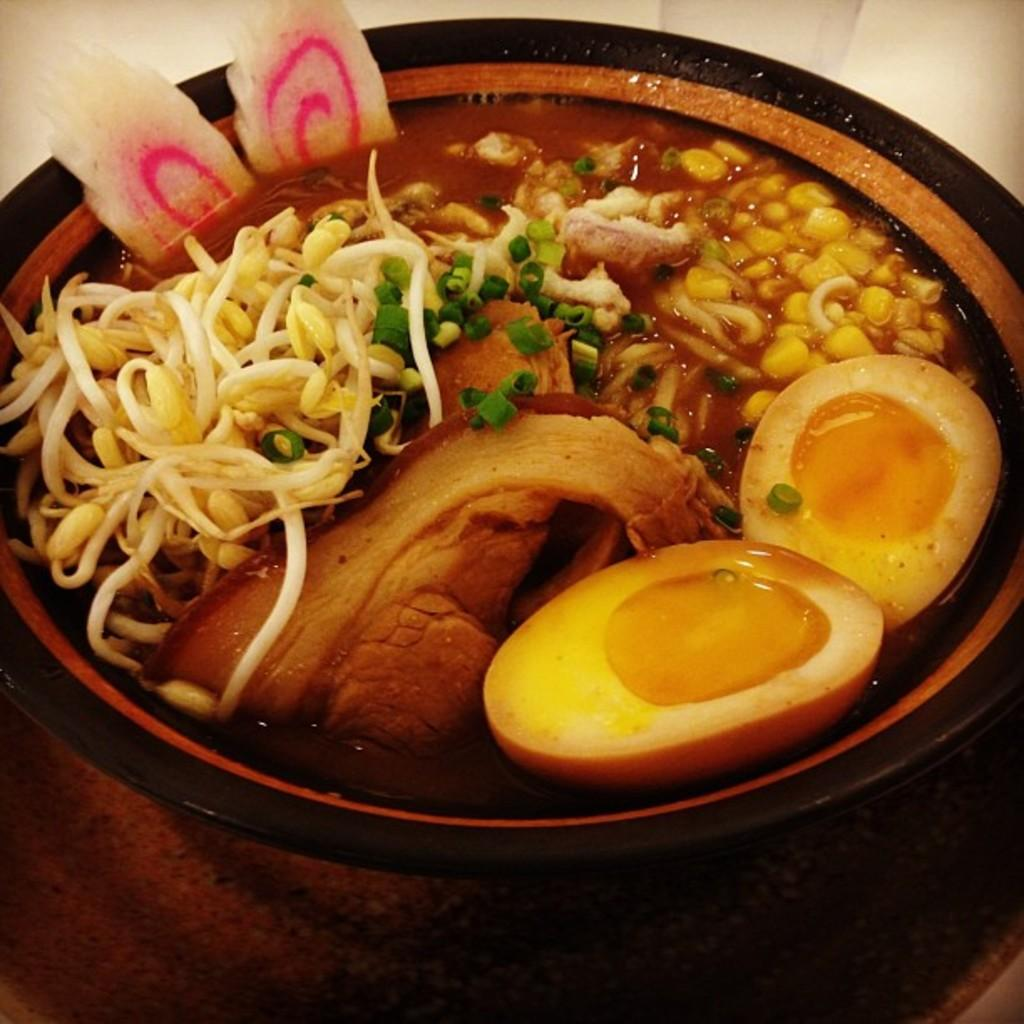What is in the bowl that is visible in the image? The bowl contains egg pieces, meat, seeds, and other food items. Can you describe the contents of the bowl in more detail? The bowl contains egg pieces, meat, seeds, and other food items, such as vegetables or grains. Where is the bowl located in the image? The bowl is on a surface in the image. Is there a servant in the image serving the food in the bowl? There is no servant present in the image. Can you tell me what type of bear is sitting next to the bowl? There is no bear present in the image. 